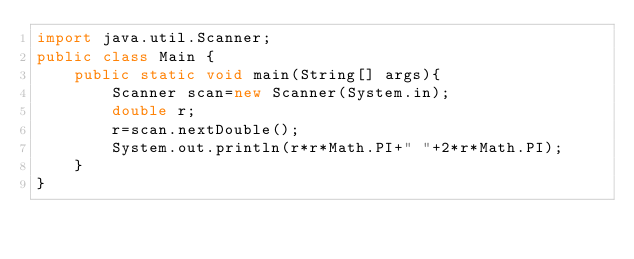Convert code to text. <code><loc_0><loc_0><loc_500><loc_500><_Java_>import java.util.Scanner;
public class Main {
	public static void main(String[] args){
		Scanner scan=new Scanner(System.in);
		double r;
		r=scan.nextDouble();
		System.out.println(r*r*Math.PI+" "+2*r*Math.PI);
	}
}

</code> 